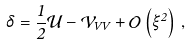<formula> <loc_0><loc_0><loc_500><loc_500>\delta = \frac { 1 } { 2 } \mathcal { U } - \mathcal { V } _ { V V } + \mathcal { O } \left ( \xi ^ { 2 } \right ) \, ,</formula> 